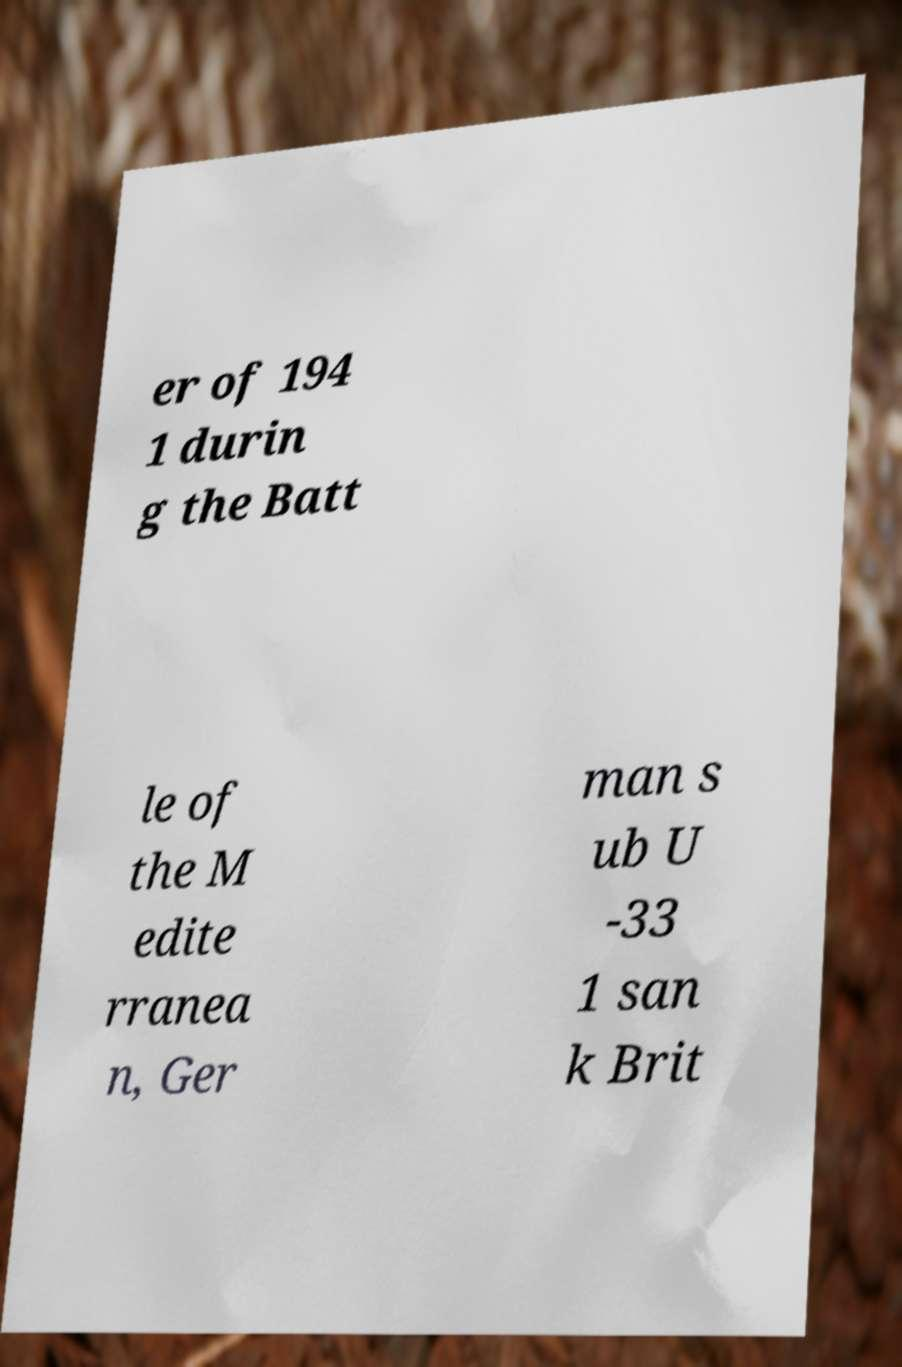Could you assist in decoding the text presented in this image and type it out clearly? er of 194 1 durin g the Batt le of the M edite rranea n, Ger man s ub U -33 1 san k Brit 